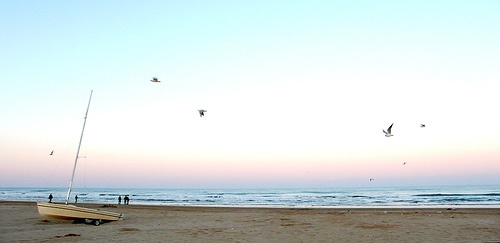Describe the objects in this image and their specific colors. I can see boat in lightblue, tan, gray, black, and olive tones, people in lightblue, black, gray, teal, and darkblue tones, bird in lightblue, darkgray, gray, black, and lightgray tones, bird in lightblue, darkgray, gray, and lightgray tones, and bird in lightblue, darkgray, gray, and black tones in this image. 